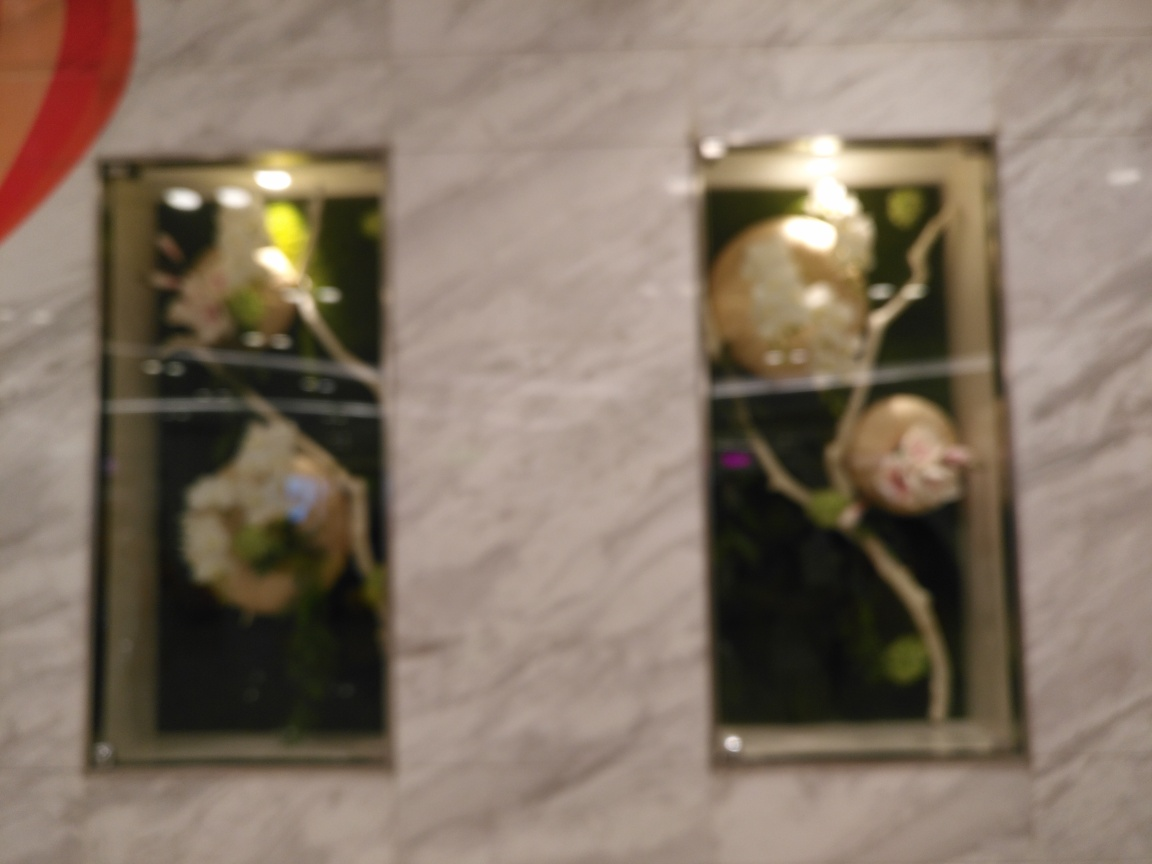Are there any elements in the photo that you think should be particularly focused on to enhance its overall appeal? Focusing on the framed wall art would notably enhance the photo's appeal, bringing out the details of what appears to be floral arrangements within them. Additionally, ensuring that the texture of the wall is sharp and clearly visible would add to the image's aesthetic by providing a contrast between the subject (the wall art) and its background (the wall). 